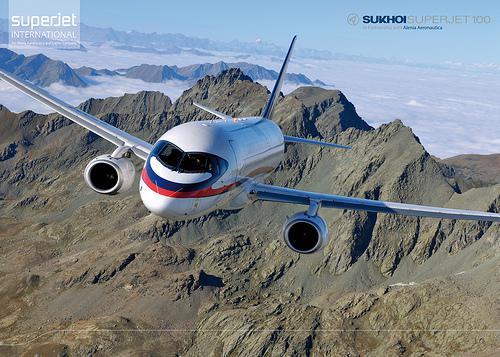Question: what is in the background?
Choices:
A. Valley.
B. Mountains.
C. River.
D. Horizon.
Answer with the letter. Answer: B Question: what is the motion of the water?
Choices:
A. Wavy.
B. Still.
C. There isn't any.
D. Stormy.
Answer with the letter. Answer: A Question: where is the airplane?
Choices:
A. Landing.
B. Taking off.
C. Air.
D. Crashed into sea.
Answer with the letter. Answer: C 